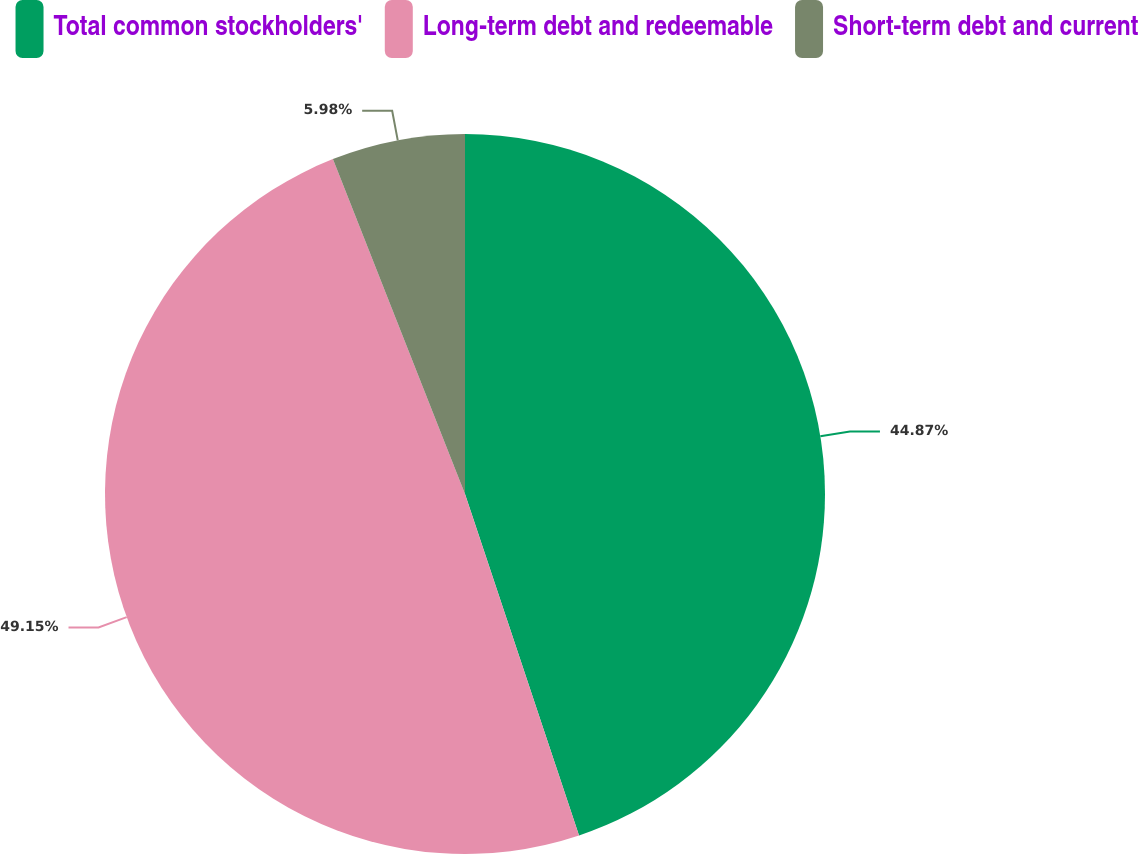Convert chart. <chart><loc_0><loc_0><loc_500><loc_500><pie_chart><fcel>Total common stockholders'<fcel>Long-term debt and redeemable<fcel>Short-term debt and current<nl><fcel>44.87%<fcel>49.15%<fcel>5.98%<nl></chart> 